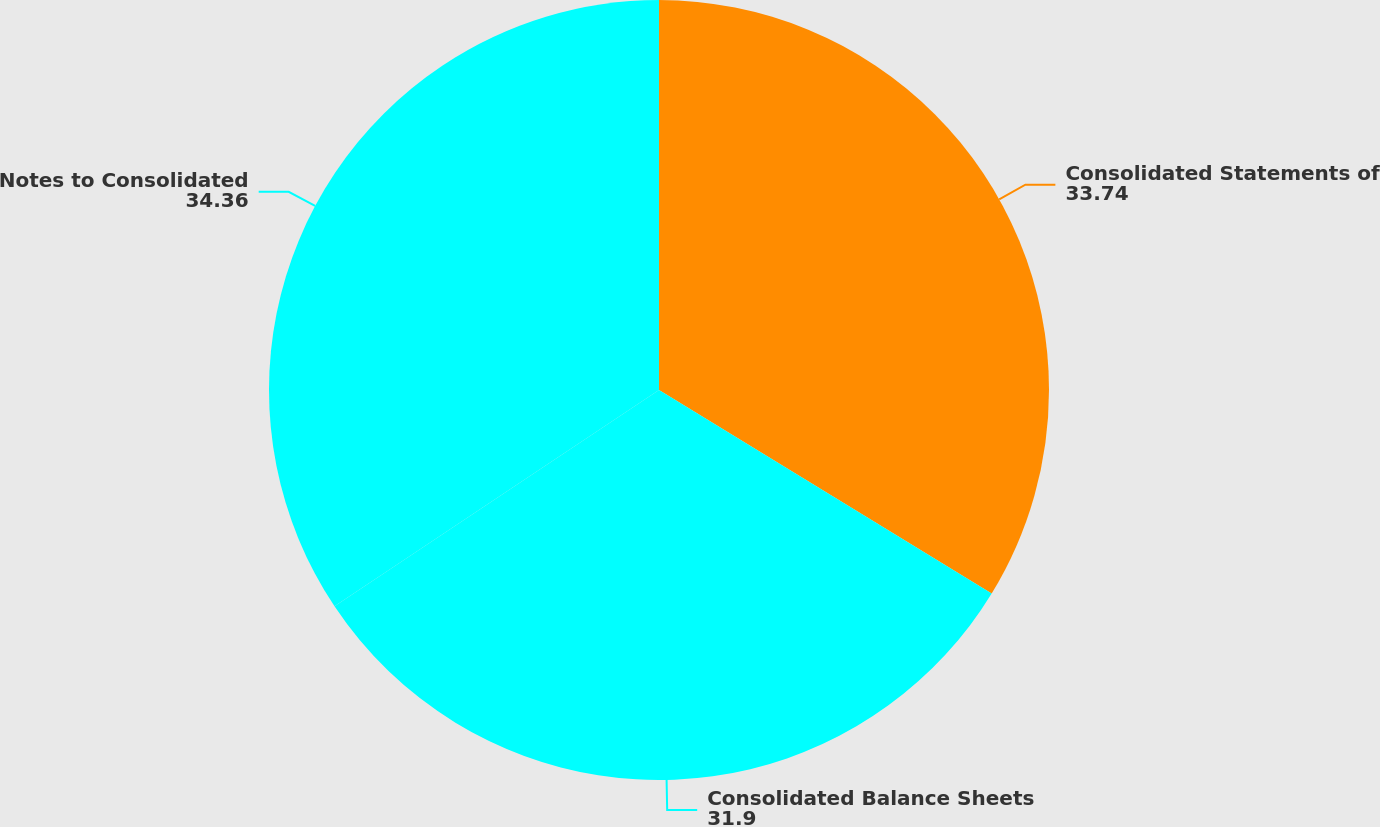Convert chart to OTSL. <chart><loc_0><loc_0><loc_500><loc_500><pie_chart><fcel>Consolidated Statements of<fcel>Consolidated Balance Sheets<fcel>Notes to Consolidated<nl><fcel>33.74%<fcel>31.9%<fcel>34.36%<nl></chart> 